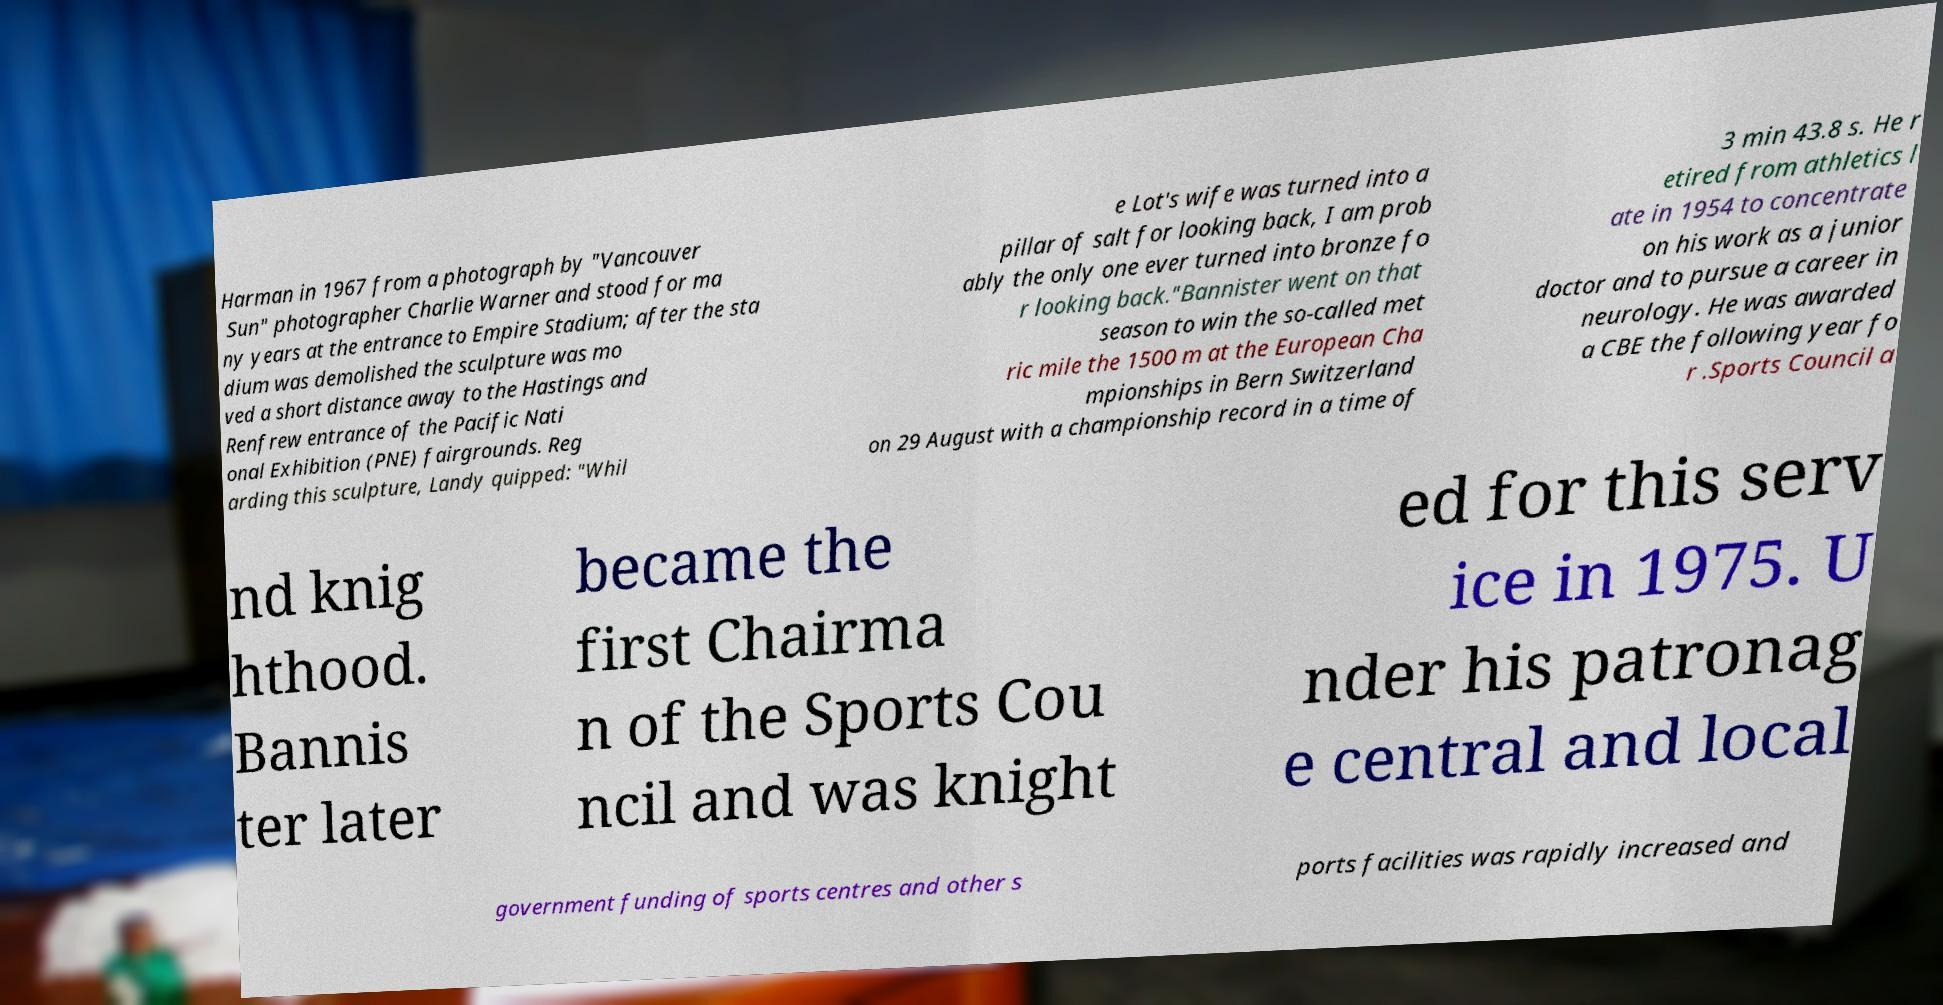For documentation purposes, I need the text within this image transcribed. Could you provide that? Harman in 1967 from a photograph by "Vancouver Sun" photographer Charlie Warner and stood for ma ny years at the entrance to Empire Stadium; after the sta dium was demolished the sculpture was mo ved a short distance away to the Hastings and Renfrew entrance of the Pacific Nati onal Exhibition (PNE) fairgrounds. Reg arding this sculpture, Landy quipped: "Whil e Lot's wife was turned into a pillar of salt for looking back, I am prob ably the only one ever turned into bronze fo r looking back."Bannister went on that season to win the so-called met ric mile the 1500 m at the European Cha mpionships in Bern Switzerland on 29 August with a championship record in a time of 3 min 43.8 s. He r etired from athletics l ate in 1954 to concentrate on his work as a junior doctor and to pursue a career in neurology. He was awarded a CBE the following year fo r .Sports Council a nd knig hthood. Bannis ter later became the first Chairma n of the Sports Cou ncil and was knight ed for this serv ice in 1975. U nder his patronag e central and local government funding of sports centres and other s ports facilities was rapidly increased and 